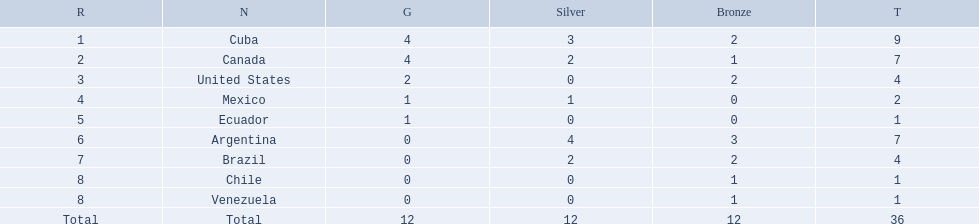Which nations won a gold medal in canoeing in the 2011 pan american games? Cuba, Canada, United States, Mexico, Ecuador. Which of these did not win any silver medals? United States. 